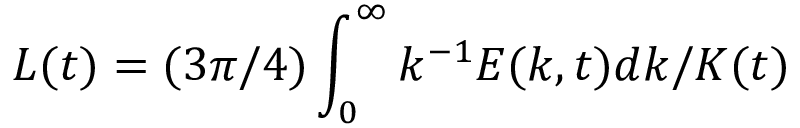Convert formula to latex. <formula><loc_0><loc_0><loc_500><loc_500>L ( t ) = ( 3 \pi / 4 ) \int _ { 0 } ^ { \infty } k ^ { - 1 } E ( k , t ) d k / K ( t )</formula> 